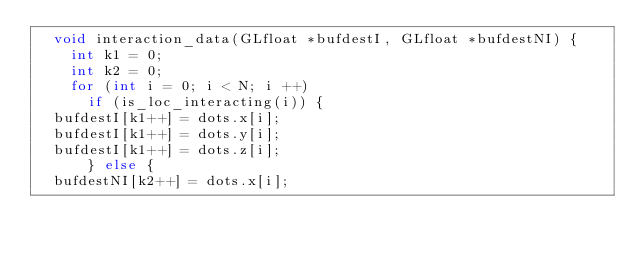<code> <loc_0><loc_0><loc_500><loc_500><_C++_>  void interaction_data(GLfloat *bufdestI, GLfloat *bufdestNI) {
    int k1 = 0;
    int k2 = 0;
    for (int i = 0; i < N; i ++)
      if (is_loc_interacting(i)) {
	bufdestI[k1++] = dots.x[i];
	bufdestI[k1++] = dots.y[i];
	bufdestI[k1++] = dots.z[i];
      } else {
	bufdestNI[k2++] = dots.x[i];</code> 